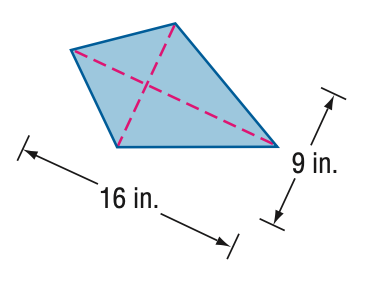Answer the mathemtical geometry problem and directly provide the correct option letter.
Question: Find the area of the kite.
Choices: A: 72 B: 80 C: 88 D: 96 A 